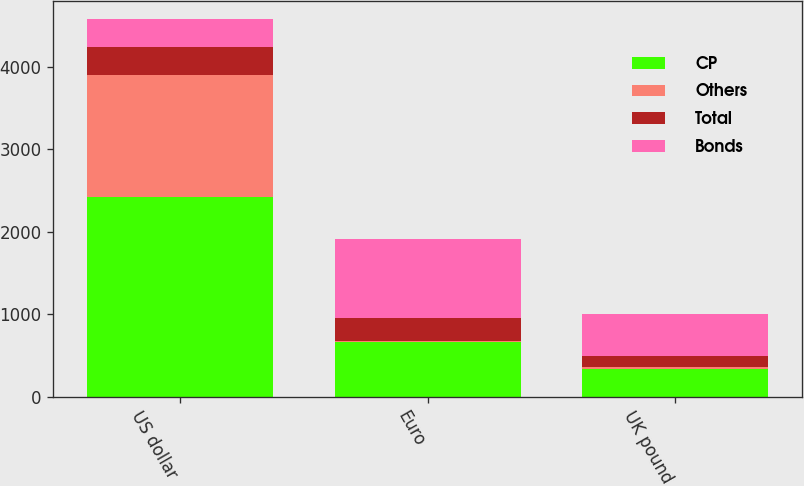Convert chart to OTSL. <chart><loc_0><loc_0><loc_500><loc_500><stacked_bar_chart><ecel><fcel>US dollar<fcel>Euro<fcel>UK pound<nl><fcel>CP<fcel>2422<fcel>665<fcel>339<nl><fcel>Others<fcel>1475<fcel>6<fcel>24<nl><fcel>Total<fcel>335<fcel>284<fcel>135<nl><fcel>Bonds<fcel>339<fcel>955<fcel>498<nl></chart> 